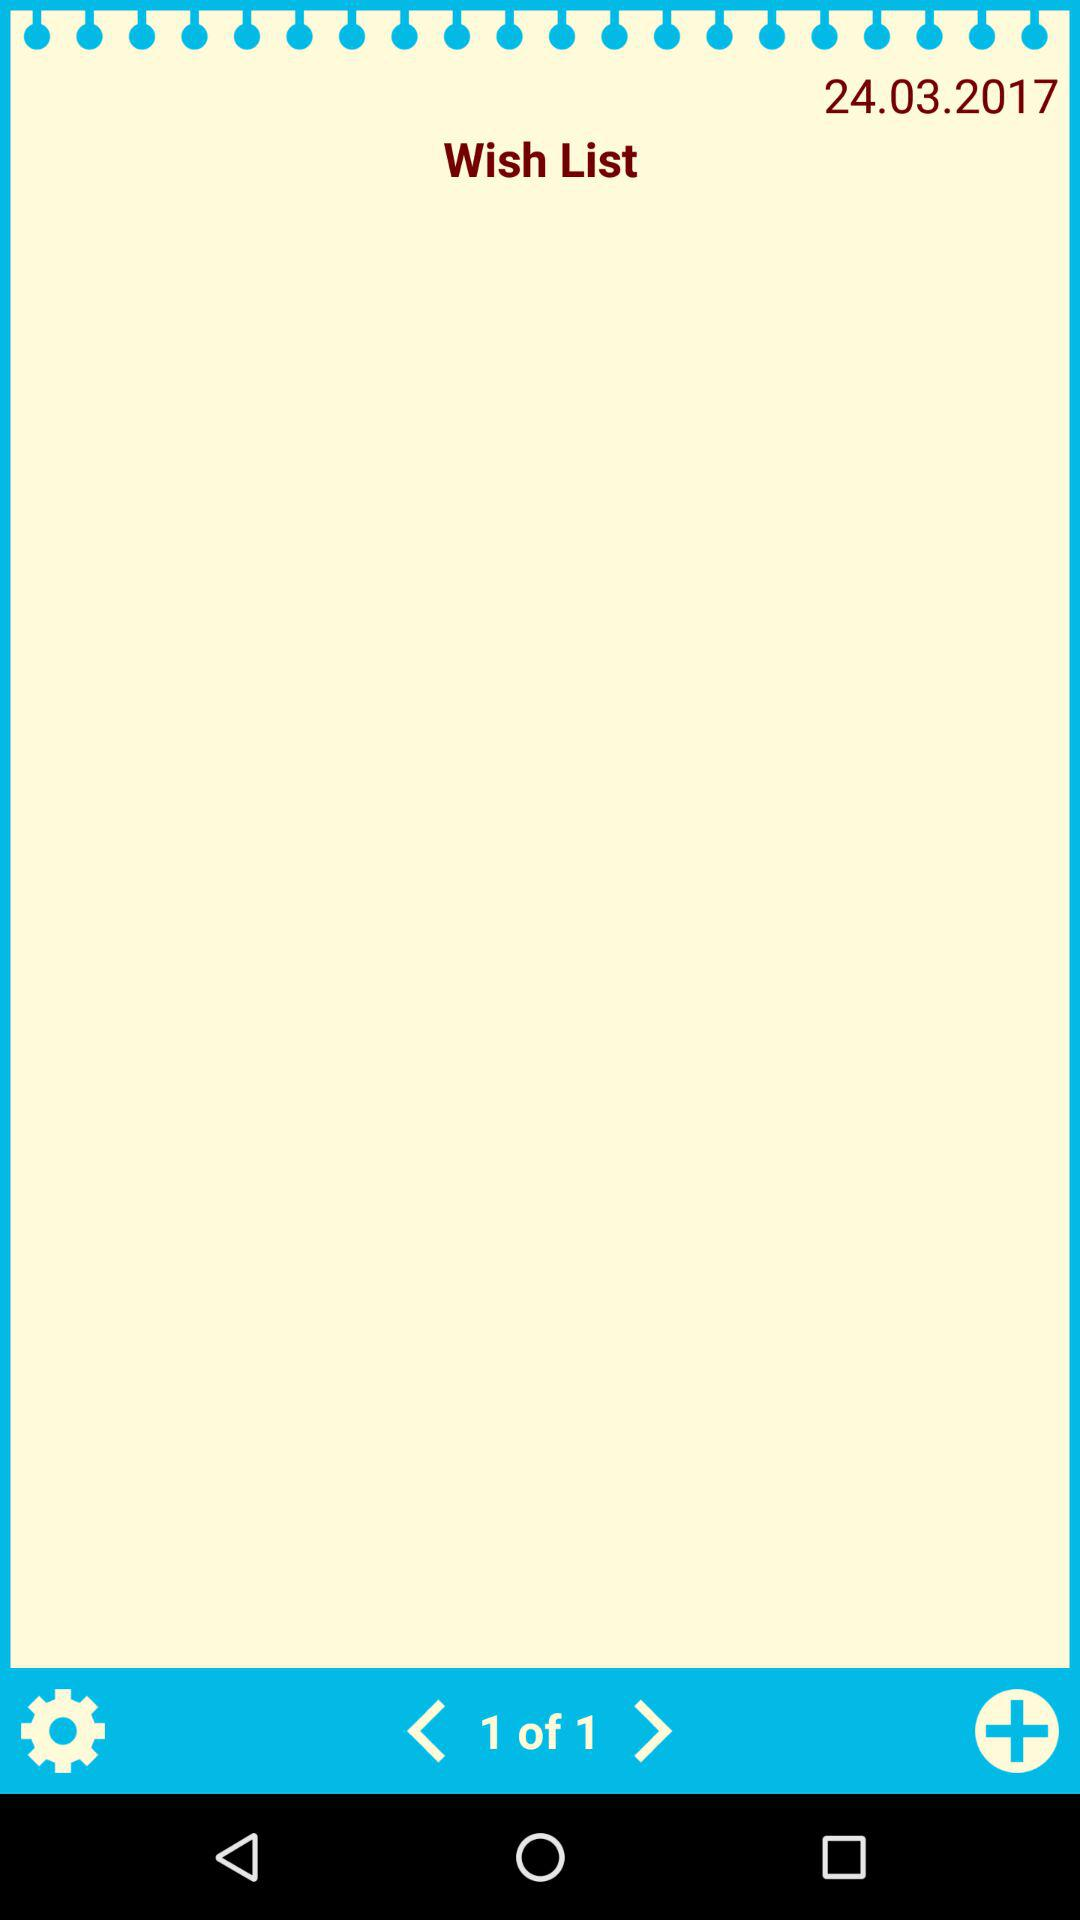How many wishes can be added to the list?
When the provided information is insufficient, respond with <no answer>. <no answer> 